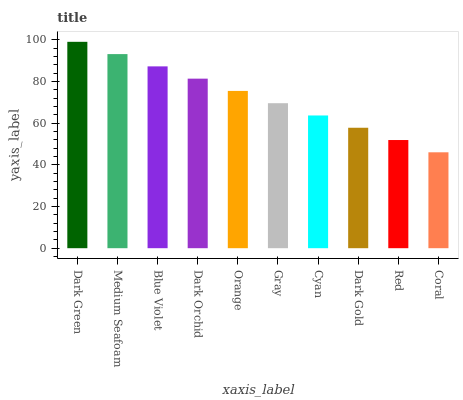Is Coral the minimum?
Answer yes or no. Yes. Is Dark Green the maximum?
Answer yes or no. Yes. Is Medium Seafoam the minimum?
Answer yes or no. No. Is Medium Seafoam the maximum?
Answer yes or no. No. Is Dark Green greater than Medium Seafoam?
Answer yes or no. Yes. Is Medium Seafoam less than Dark Green?
Answer yes or no. Yes. Is Medium Seafoam greater than Dark Green?
Answer yes or no. No. Is Dark Green less than Medium Seafoam?
Answer yes or no. No. Is Orange the high median?
Answer yes or no. Yes. Is Gray the low median?
Answer yes or no. Yes. Is Blue Violet the high median?
Answer yes or no. No. Is Dark Green the low median?
Answer yes or no. No. 